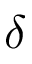<formula> <loc_0><loc_0><loc_500><loc_500>\delta</formula> 